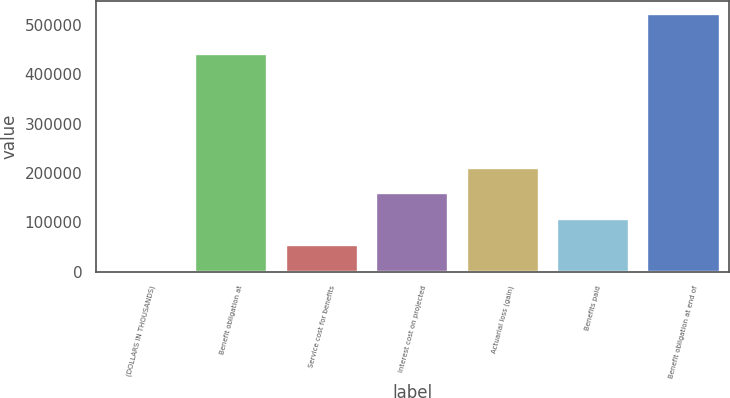<chart> <loc_0><loc_0><loc_500><loc_500><bar_chart><fcel>(DOLLARS IN THOUSANDS)<fcel>Benefit obligation at<fcel>Service cost for benefits<fcel>Interest cost on projected<fcel>Actuarial loss (gain)<fcel>Benefits paid<fcel>Benefit obligation at end of<nl><fcel>2011<fcel>440646<fcel>54139.7<fcel>158397<fcel>210526<fcel>106268<fcel>523298<nl></chart> 